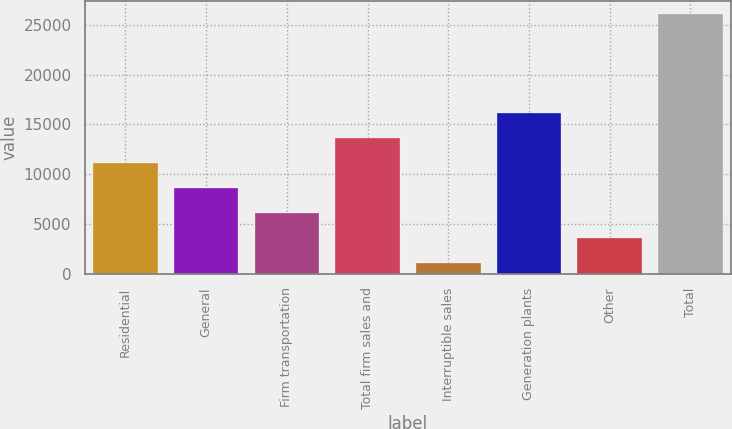Convert chart to OTSL. <chart><loc_0><loc_0><loc_500><loc_500><bar_chart><fcel>Residential<fcel>General<fcel>Firm transportation<fcel>Total firm sales and<fcel>Interruptible sales<fcel>Generation plants<fcel>Other<fcel>Total<nl><fcel>11129.4<fcel>8630.3<fcel>6131.2<fcel>13628.5<fcel>1133<fcel>16127.6<fcel>3632.1<fcel>26124<nl></chart> 